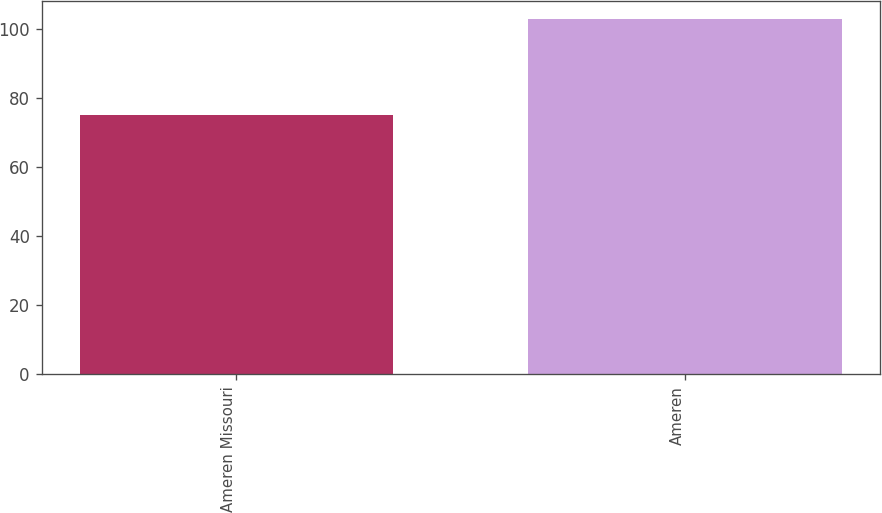Convert chart. <chart><loc_0><loc_0><loc_500><loc_500><bar_chart><fcel>Ameren Missouri<fcel>Ameren<nl><fcel>75<fcel>103<nl></chart> 